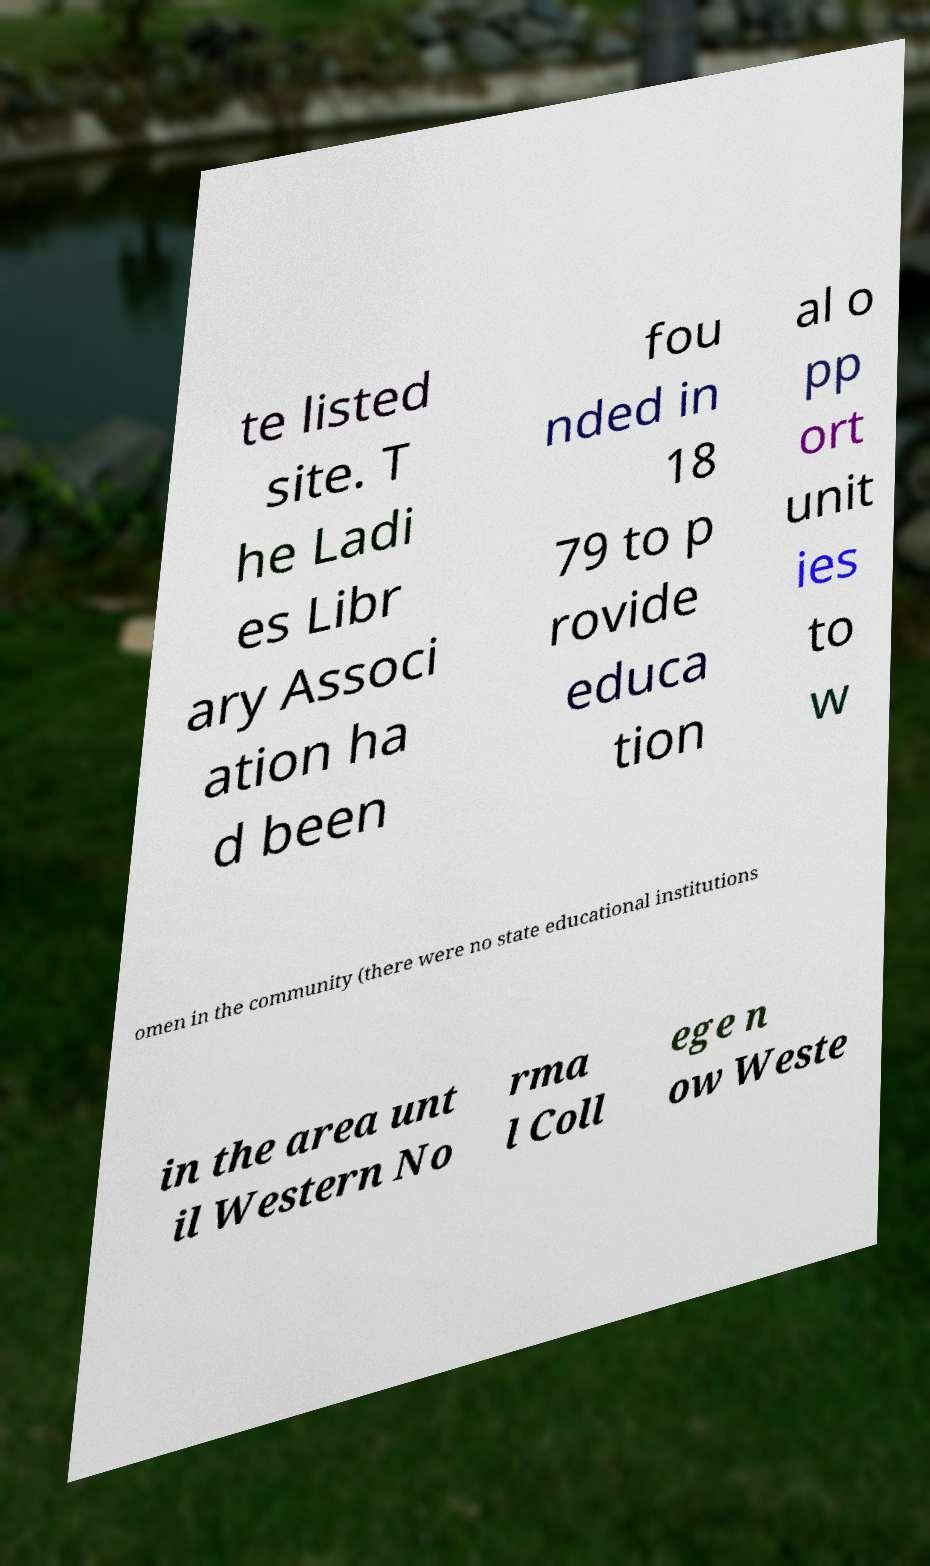For documentation purposes, I need the text within this image transcribed. Could you provide that? te listed site. T he Ladi es Libr ary Associ ation ha d been fou nded in 18 79 to p rovide educa tion al o pp ort unit ies to w omen in the community (there were no state educational institutions in the area unt il Western No rma l Coll ege n ow Weste 